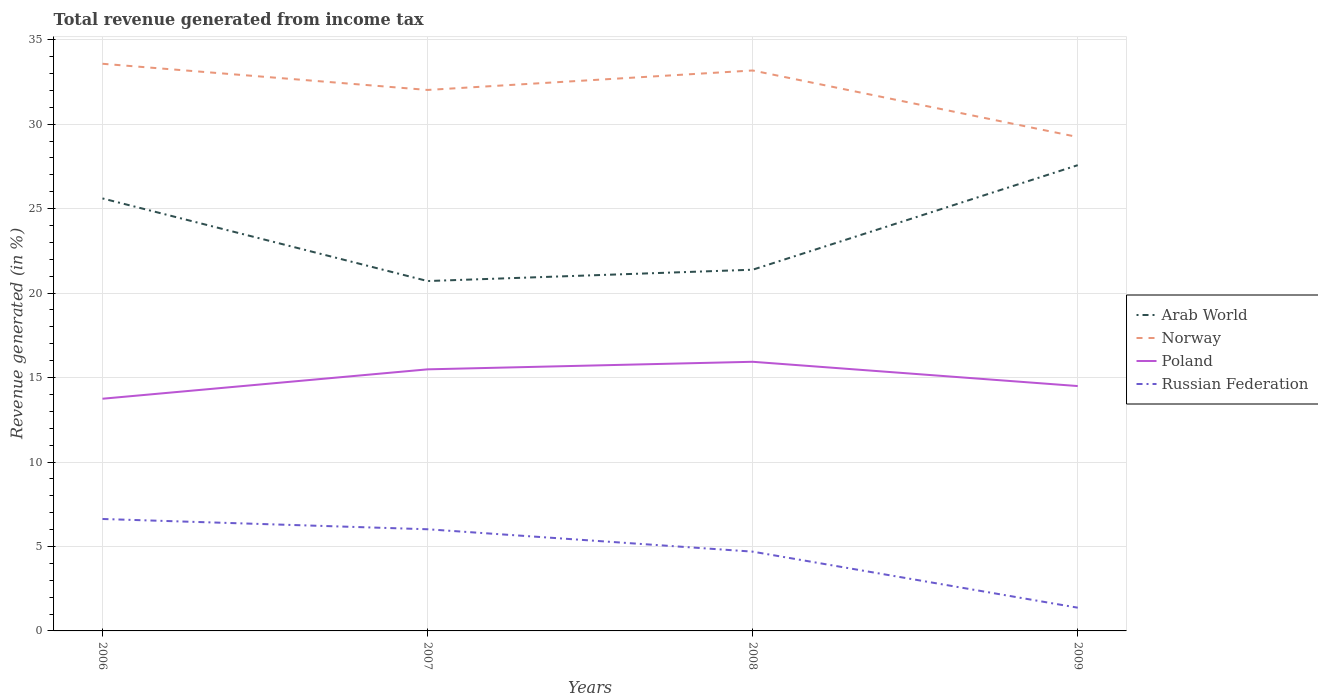Does the line corresponding to Arab World intersect with the line corresponding to Poland?
Your answer should be very brief. No. Across all years, what is the maximum total revenue generated in Poland?
Offer a terse response. 13.75. What is the total total revenue generated in Arab World in the graph?
Provide a succinct answer. -1.97. What is the difference between the highest and the second highest total revenue generated in Norway?
Provide a succinct answer. 4.34. What is the difference between the highest and the lowest total revenue generated in Arab World?
Ensure brevity in your answer.  2. Is the total revenue generated in Poland strictly greater than the total revenue generated in Russian Federation over the years?
Your answer should be compact. No. How many years are there in the graph?
Your answer should be very brief. 4. Does the graph contain any zero values?
Your answer should be very brief. No. Does the graph contain grids?
Provide a succinct answer. Yes. Where does the legend appear in the graph?
Provide a short and direct response. Center right. How are the legend labels stacked?
Provide a short and direct response. Vertical. What is the title of the graph?
Offer a terse response. Total revenue generated from income tax. Does "Rwanda" appear as one of the legend labels in the graph?
Give a very brief answer. No. What is the label or title of the Y-axis?
Provide a short and direct response. Revenue generated (in %). What is the Revenue generated (in %) in Arab World in 2006?
Give a very brief answer. 25.61. What is the Revenue generated (in %) of Norway in 2006?
Your response must be concise. 33.58. What is the Revenue generated (in %) in Poland in 2006?
Offer a very short reply. 13.75. What is the Revenue generated (in %) in Russian Federation in 2006?
Give a very brief answer. 6.63. What is the Revenue generated (in %) in Arab World in 2007?
Offer a very short reply. 20.71. What is the Revenue generated (in %) in Norway in 2007?
Keep it short and to the point. 32.03. What is the Revenue generated (in %) in Poland in 2007?
Provide a succinct answer. 15.49. What is the Revenue generated (in %) in Russian Federation in 2007?
Offer a very short reply. 6.02. What is the Revenue generated (in %) in Arab World in 2008?
Your response must be concise. 21.38. What is the Revenue generated (in %) of Norway in 2008?
Offer a very short reply. 33.18. What is the Revenue generated (in %) in Poland in 2008?
Give a very brief answer. 15.93. What is the Revenue generated (in %) in Russian Federation in 2008?
Your answer should be very brief. 4.69. What is the Revenue generated (in %) of Arab World in 2009?
Keep it short and to the point. 27.57. What is the Revenue generated (in %) of Norway in 2009?
Make the answer very short. 29.24. What is the Revenue generated (in %) in Poland in 2009?
Your response must be concise. 14.5. What is the Revenue generated (in %) of Russian Federation in 2009?
Provide a short and direct response. 1.38. Across all years, what is the maximum Revenue generated (in %) in Arab World?
Your answer should be compact. 27.57. Across all years, what is the maximum Revenue generated (in %) of Norway?
Ensure brevity in your answer.  33.58. Across all years, what is the maximum Revenue generated (in %) in Poland?
Provide a succinct answer. 15.93. Across all years, what is the maximum Revenue generated (in %) of Russian Federation?
Provide a short and direct response. 6.63. Across all years, what is the minimum Revenue generated (in %) of Arab World?
Offer a terse response. 20.71. Across all years, what is the minimum Revenue generated (in %) of Norway?
Offer a terse response. 29.24. Across all years, what is the minimum Revenue generated (in %) of Poland?
Provide a succinct answer. 13.75. Across all years, what is the minimum Revenue generated (in %) in Russian Federation?
Your answer should be compact. 1.38. What is the total Revenue generated (in %) of Arab World in the graph?
Your answer should be very brief. 95.28. What is the total Revenue generated (in %) in Norway in the graph?
Provide a short and direct response. 128.03. What is the total Revenue generated (in %) in Poland in the graph?
Provide a short and direct response. 59.66. What is the total Revenue generated (in %) in Russian Federation in the graph?
Give a very brief answer. 18.71. What is the difference between the Revenue generated (in %) in Arab World in 2006 and that in 2007?
Your answer should be very brief. 4.89. What is the difference between the Revenue generated (in %) of Norway in 2006 and that in 2007?
Give a very brief answer. 1.55. What is the difference between the Revenue generated (in %) in Poland in 2006 and that in 2007?
Make the answer very short. -1.74. What is the difference between the Revenue generated (in %) in Russian Federation in 2006 and that in 2007?
Provide a succinct answer. 0.61. What is the difference between the Revenue generated (in %) in Arab World in 2006 and that in 2008?
Make the answer very short. 4.22. What is the difference between the Revenue generated (in %) in Norway in 2006 and that in 2008?
Provide a short and direct response. 0.4. What is the difference between the Revenue generated (in %) of Poland in 2006 and that in 2008?
Offer a terse response. -2.19. What is the difference between the Revenue generated (in %) in Russian Federation in 2006 and that in 2008?
Your response must be concise. 1.93. What is the difference between the Revenue generated (in %) in Arab World in 2006 and that in 2009?
Give a very brief answer. -1.97. What is the difference between the Revenue generated (in %) of Norway in 2006 and that in 2009?
Keep it short and to the point. 4.34. What is the difference between the Revenue generated (in %) in Poland in 2006 and that in 2009?
Your answer should be compact. -0.75. What is the difference between the Revenue generated (in %) in Russian Federation in 2006 and that in 2009?
Your answer should be very brief. 5.25. What is the difference between the Revenue generated (in %) of Arab World in 2007 and that in 2008?
Ensure brevity in your answer.  -0.67. What is the difference between the Revenue generated (in %) in Norway in 2007 and that in 2008?
Keep it short and to the point. -1.15. What is the difference between the Revenue generated (in %) in Poland in 2007 and that in 2008?
Keep it short and to the point. -0.45. What is the difference between the Revenue generated (in %) of Russian Federation in 2007 and that in 2008?
Give a very brief answer. 1.32. What is the difference between the Revenue generated (in %) in Arab World in 2007 and that in 2009?
Give a very brief answer. -6.86. What is the difference between the Revenue generated (in %) in Norway in 2007 and that in 2009?
Provide a succinct answer. 2.79. What is the difference between the Revenue generated (in %) of Poland in 2007 and that in 2009?
Your answer should be compact. 0.99. What is the difference between the Revenue generated (in %) in Russian Federation in 2007 and that in 2009?
Provide a succinct answer. 4.64. What is the difference between the Revenue generated (in %) in Arab World in 2008 and that in 2009?
Make the answer very short. -6.19. What is the difference between the Revenue generated (in %) of Norway in 2008 and that in 2009?
Your answer should be compact. 3.94. What is the difference between the Revenue generated (in %) of Poland in 2008 and that in 2009?
Make the answer very short. 1.44. What is the difference between the Revenue generated (in %) of Russian Federation in 2008 and that in 2009?
Give a very brief answer. 3.32. What is the difference between the Revenue generated (in %) of Arab World in 2006 and the Revenue generated (in %) of Norway in 2007?
Provide a short and direct response. -6.42. What is the difference between the Revenue generated (in %) in Arab World in 2006 and the Revenue generated (in %) in Poland in 2007?
Offer a terse response. 10.12. What is the difference between the Revenue generated (in %) of Arab World in 2006 and the Revenue generated (in %) of Russian Federation in 2007?
Provide a succinct answer. 19.59. What is the difference between the Revenue generated (in %) in Norway in 2006 and the Revenue generated (in %) in Poland in 2007?
Offer a very short reply. 18.09. What is the difference between the Revenue generated (in %) of Norway in 2006 and the Revenue generated (in %) of Russian Federation in 2007?
Your answer should be very brief. 27.56. What is the difference between the Revenue generated (in %) in Poland in 2006 and the Revenue generated (in %) in Russian Federation in 2007?
Give a very brief answer. 7.73. What is the difference between the Revenue generated (in %) in Arab World in 2006 and the Revenue generated (in %) in Norway in 2008?
Your answer should be compact. -7.57. What is the difference between the Revenue generated (in %) of Arab World in 2006 and the Revenue generated (in %) of Poland in 2008?
Make the answer very short. 9.67. What is the difference between the Revenue generated (in %) of Arab World in 2006 and the Revenue generated (in %) of Russian Federation in 2008?
Your response must be concise. 20.91. What is the difference between the Revenue generated (in %) of Norway in 2006 and the Revenue generated (in %) of Poland in 2008?
Keep it short and to the point. 17.64. What is the difference between the Revenue generated (in %) in Norway in 2006 and the Revenue generated (in %) in Russian Federation in 2008?
Offer a terse response. 28.88. What is the difference between the Revenue generated (in %) in Poland in 2006 and the Revenue generated (in %) in Russian Federation in 2008?
Your response must be concise. 9.05. What is the difference between the Revenue generated (in %) in Arab World in 2006 and the Revenue generated (in %) in Norway in 2009?
Offer a terse response. -3.63. What is the difference between the Revenue generated (in %) of Arab World in 2006 and the Revenue generated (in %) of Poland in 2009?
Keep it short and to the point. 11.11. What is the difference between the Revenue generated (in %) of Arab World in 2006 and the Revenue generated (in %) of Russian Federation in 2009?
Your response must be concise. 24.23. What is the difference between the Revenue generated (in %) in Norway in 2006 and the Revenue generated (in %) in Poland in 2009?
Keep it short and to the point. 19.08. What is the difference between the Revenue generated (in %) in Norway in 2006 and the Revenue generated (in %) in Russian Federation in 2009?
Provide a succinct answer. 32.2. What is the difference between the Revenue generated (in %) of Poland in 2006 and the Revenue generated (in %) of Russian Federation in 2009?
Provide a succinct answer. 12.37. What is the difference between the Revenue generated (in %) in Arab World in 2007 and the Revenue generated (in %) in Norway in 2008?
Provide a succinct answer. -12.47. What is the difference between the Revenue generated (in %) of Arab World in 2007 and the Revenue generated (in %) of Poland in 2008?
Provide a short and direct response. 4.78. What is the difference between the Revenue generated (in %) in Arab World in 2007 and the Revenue generated (in %) in Russian Federation in 2008?
Your answer should be very brief. 16.02. What is the difference between the Revenue generated (in %) in Norway in 2007 and the Revenue generated (in %) in Poland in 2008?
Your answer should be very brief. 16.09. What is the difference between the Revenue generated (in %) in Norway in 2007 and the Revenue generated (in %) in Russian Federation in 2008?
Give a very brief answer. 27.33. What is the difference between the Revenue generated (in %) in Poland in 2007 and the Revenue generated (in %) in Russian Federation in 2008?
Make the answer very short. 10.79. What is the difference between the Revenue generated (in %) of Arab World in 2007 and the Revenue generated (in %) of Norway in 2009?
Your response must be concise. -8.53. What is the difference between the Revenue generated (in %) of Arab World in 2007 and the Revenue generated (in %) of Poland in 2009?
Your response must be concise. 6.22. What is the difference between the Revenue generated (in %) of Arab World in 2007 and the Revenue generated (in %) of Russian Federation in 2009?
Your answer should be very brief. 19.34. What is the difference between the Revenue generated (in %) of Norway in 2007 and the Revenue generated (in %) of Poland in 2009?
Keep it short and to the point. 17.53. What is the difference between the Revenue generated (in %) in Norway in 2007 and the Revenue generated (in %) in Russian Federation in 2009?
Your answer should be compact. 30.65. What is the difference between the Revenue generated (in %) of Poland in 2007 and the Revenue generated (in %) of Russian Federation in 2009?
Give a very brief answer. 14.11. What is the difference between the Revenue generated (in %) of Arab World in 2008 and the Revenue generated (in %) of Norway in 2009?
Make the answer very short. -7.86. What is the difference between the Revenue generated (in %) in Arab World in 2008 and the Revenue generated (in %) in Poland in 2009?
Provide a succinct answer. 6.89. What is the difference between the Revenue generated (in %) in Arab World in 2008 and the Revenue generated (in %) in Russian Federation in 2009?
Keep it short and to the point. 20.01. What is the difference between the Revenue generated (in %) in Norway in 2008 and the Revenue generated (in %) in Poland in 2009?
Make the answer very short. 18.68. What is the difference between the Revenue generated (in %) in Norway in 2008 and the Revenue generated (in %) in Russian Federation in 2009?
Your response must be concise. 31.8. What is the difference between the Revenue generated (in %) of Poland in 2008 and the Revenue generated (in %) of Russian Federation in 2009?
Give a very brief answer. 14.56. What is the average Revenue generated (in %) of Arab World per year?
Your answer should be very brief. 23.82. What is the average Revenue generated (in %) of Norway per year?
Your response must be concise. 32.01. What is the average Revenue generated (in %) of Poland per year?
Your answer should be very brief. 14.92. What is the average Revenue generated (in %) of Russian Federation per year?
Ensure brevity in your answer.  4.68. In the year 2006, what is the difference between the Revenue generated (in %) in Arab World and Revenue generated (in %) in Norway?
Provide a succinct answer. -7.97. In the year 2006, what is the difference between the Revenue generated (in %) of Arab World and Revenue generated (in %) of Poland?
Offer a very short reply. 11.86. In the year 2006, what is the difference between the Revenue generated (in %) of Arab World and Revenue generated (in %) of Russian Federation?
Offer a very short reply. 18.98. In the year 2006, what is the difference between the Revenue generated (in %) in Norway and Revenue generated (in %) in Poland?
Offer a very short reply. 19.83. In the year 2006, what is the difference between the Revenue generated (in %) of Norway and Revenue generated (in %) of Russian Federation?
Offer a very short reply. 26.95. In the year 2006, what is the difference between the Revenue generated (in %) in Poland and Revenue generated (in %) in Russian Federation?
Your response must be concise. 7.12. In the year 2007, what is the difference between the Revenue generated (in %) in Arab World and Revenue generated (in %) in Norway?
Keep it short and to the point. -11.31. In the year 2007, what is the difference between the Revenue generated (in %) of Arab World and Revenue generated (in %) of Poland?
Ensure brevity in your answer.  5.23. In the year 2007, what is the difference between the Revenue generated (in %) in Arab World and Revenue generated (in %) in Russian Federation?
Keep it short and to the point. 14.7. In the year 2007, what is the difference between the Revenue generated (in %) in Norway and Revenue generated (in %) in Poland?
Your response must be concise. 16.54. In the year 2007, what is the difference between the Revenue generated (in %) in Norway and Revenue generated (in %) in Russian Federation?
Make the answer very short. 26.01. In the year 2007, what is the difference between the Revenue generated (in %) in Poland and Revenue generated (in %) in Russian Federation?
Provide a succinct answer. 9.47. In the year 2008, what is the difference between the Revenue generated (in %) in Arab World and Revenue generated (in %) in Norway?
Your response must be concise. -11.8. In the year 2008, what is the difference between the Revenue generated (in %) in Arab World and Revenue generated (in %) in Poland?
Provide a succinct answer. 5.45. In the year 2008, what is the difference between the Revenue generated (in %) in Arab World and Revenue generated (in %) in Russian Federation?
Ensure brevity in your answer.  16.69. In the year 2008, what is the difference between the Revenue generated (in %) in Norway and Revenue generated (in %) in Poland?
Ensure brevity in your answer.  17.25. In the year 2008, what is the difference between the Revenue generated (in %) of Norway and Revenue generated (in %) of Russian Federation?
Your answer should be very brief. 28.49. In the year 2008, what is the difference between the Revenue generated (in %) in Poland and Revenue generated (in %) in Russian Federation?
Give a very brief answer. 11.24. In the year 2009, what is the difference between the Revenue generated (in %) of Arab World and Revenue generated (in %) of Norway?
Provide a short and direct response. -1.67. In the year 2009, what is the difference between the Revenue generated (in %) of Arab World and Revenue generated (in %) of Poland?
Make the answer very short. 13.08. In the year 2009, what is the difference between the Revenue generated (in %) in Arab World and Revenue generated (in %) in Russian Federation?
Your response must be concise. 26.2. In the year 2009, what is the difference between the Revenue generated (in %) in Norway and Revenue generated (in %) in Poland?
Provide a short and direct response. 14.74. In the year 2009, what is the difference between the Revenue generated (in %) of Norway and Revenue generated (in %) of Russian Federation?
Your response must be concise. 27.87. In the year 2009, what is the difference between the Revenue generated (in %) in Poland and Revenue generated (in %) in Russian Federation?
Provide a succinct answer. 13.12. What is the ratio of the Revenue generated (in %) of Arab World in 2006 to that in 2007?
Offer a very short reply. 1.24. What is the ratio of the Revenue generated (in %) in Norway in 2006 to that in 2007?
Your response must be concise. 1.05. What is the ratio of the Revenue generated (in %) of Poland in 2006 to that in 2007?
Your answer should be compact. 0.89. What is the ratio of the Revenue generated (in %) of Russian Federation in 2006 to that in 2007?
Provide a succinct answer. 1.1. What is the ratio of the Revenue generated (in %) of Arab World in 2006 to that in 2008?
Give a very brief answer. 1.2. What is the ratio of the Revenue generated (in %) of Norway in 2006 to that in 2008?
Make the answer very short. 1.01. What is the ratio of the Revenue generated (in %) in Poland in 2006 to that in 2008?
Your response must be concise. 0.86. What is the ratio of the Revenue generated (in %) in Russian Federation in 2006 to that in 2008?
Your answer should be very brief. 1.41. What is the ratio of the Revenue generated (in %) of Norway in 2006 to that in 2009?
Your response must be concise. 1.15. What is the ratio of the Revenue generated (in %) in Poland in 2006 to that in 2009?
Keep it short and to the point. 0.95. What is the ratio of the Revenue generated (in %) in Russian Federation in 2006 to that in 2009?
Your answer should be very brief. 4.82. What is the ratio of the Revenue generated (in %) in Arab World in 2007 to that in 2008?
Give a very brief answer. 0.97. What is the ratio of the Revenue generated (in %) of Norway in 2007 to that in 2008?
Offer a very short reply. 0.97. What is the ratio of the Revenue generated (in %) of Poland in 2007 to that in 2008?
Provide a short and direct response. 0.97. What is the ratio of the Revenue generated (in %) of Russian Federation in 2007 to that in 2008?
Give a very brief answer. 1.28. What is the ratio of the Revenue generated (in %) of Arab World in 2007 to that in 2009?
Your answer should be very brief. 0.75. What is the ratio of the Revenue generated (in %) in Norway in 2007 to that in 2009?
Provide a short and direct response. 1.1. What is the ratio of the Revenue generated (in %) of Poland in 2007 to that in 2009?
Make the answer very short. 1.07. What is the ratio of the Revenue generated (in %) of Russian Federation in 2007 to that in 2009?
Provide a succinct answer. 4.38. What is the ratio of the Revenue generated (in %) of Arab World in 2008 to that in 2009?
Provide a succinct answer. 0.78. What is the ratio of the Revenue generated (in %) in Norway in 2008 to that in 2009?
Your answer should be very brief. 1.13. What is the ratio of the Revenue generated (in %) of Poland in 2008 to that in 2009?
Offer a terse response. 1.1. What is the ratio of the Revenue generated (in %) of Russian Federation in 2008 to that in 2009?
Provide a short and direct response. 3.41. What is the difference between the highest and the second highest Revenue generated (in %) in Arab World?
Give a very brief answer. 1.97. What is the difference between the highest and the second highest Revenue generated (in %) in Norway?
Ensure brevity in your answer.  0.4. What is the difference between the highest and the second highest Revenue generated (in %) of Poland?
Offer a very short reply. 0.45. What is the difference between the highest and the second highest Revenue generated (in %) of Russian Federation?
Offer a very short reply. 0.61. What is the difference between the highest and the lowest Revenue generated (in %) in Arab World?
Your answer should be very brief. 6.86. What is the difference between the highest and the lowest Revenue generated (in %) of Norway?
Make the answer very short. 4.34. What is the difference between the highest and the lowest Revenue generated (in %) of Poland?
Ensure brevity in your answer.  2.19. What is the difference between the highest and the lowest Revenue generated (in %) of Russian Federation?
Your answer should be very brief. 5.25. 